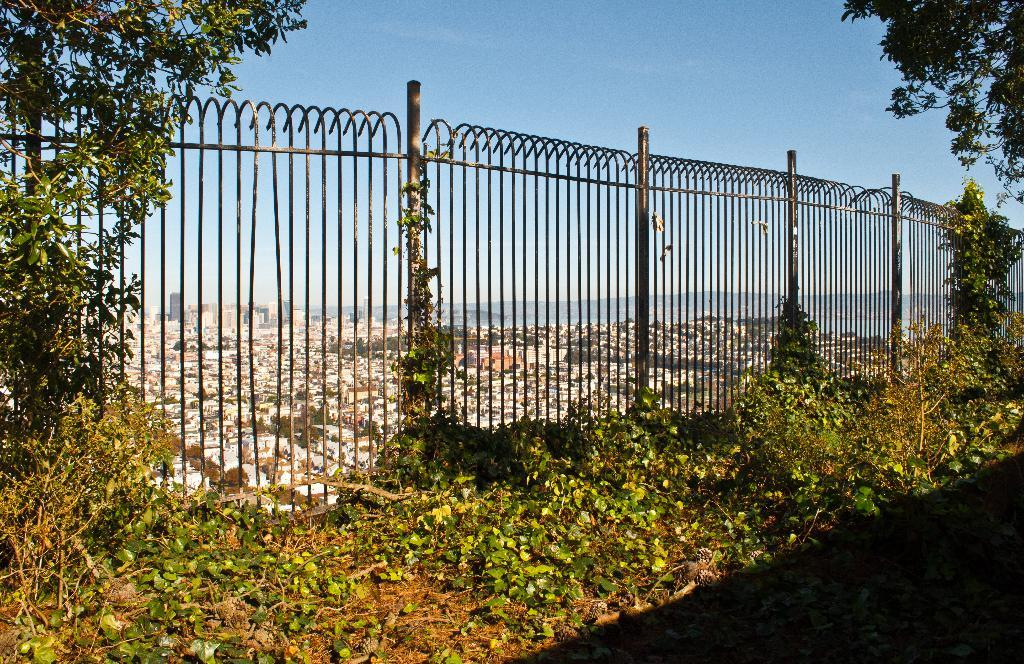What type of barrier can be seen in the image? There is a fence in the image. What type of vegetation is present in the image? There are green plants and trees in the image. What color is the sky in the image? The sky is blue in the image. How many times does the fence need to be shaken in the image? There is no indication in the image that the fence needs to be shaken, and therefore no such action can be observed. What type of base is supporting the trees in the image? The image does not show the base of the trees, so it cannot be determined from the image. 